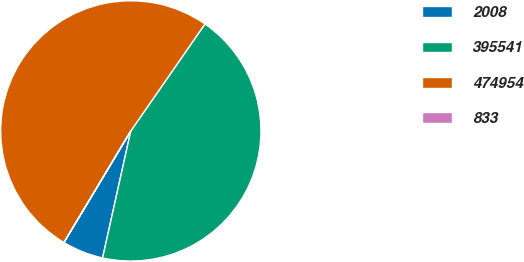Convert chart to OTSL. <chart><loc_0><loc_0><loc_500><loc_500><pie_chart><fcel>2008<fcel>395541<fcel>474954<fcel>833<nl><fcel>5.11%<fcel>43.83%<fcel>51.05%<fcel>0.01%<nl></chart> 